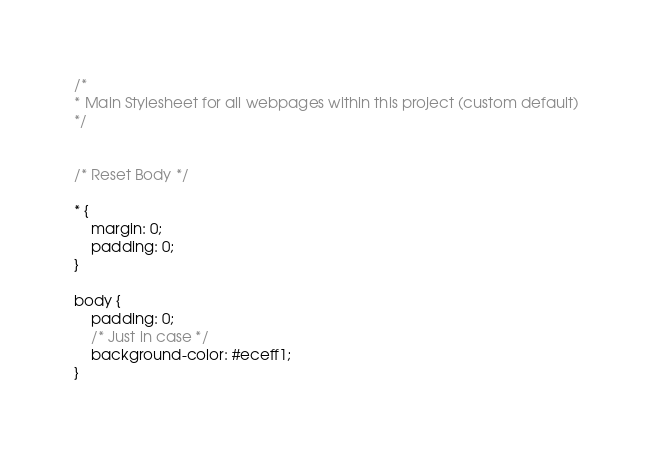<code> <loc_0><loc_0><loc_500><loc_500><_CSS_>/*
* Main Stylesheet for all webpages within this project (custom default)
*/


/* Reset Body */

* {
    margin: 0;
    padding: 0;
}

body {
    padding: 0;
    /* Just in case */
    background-color: #eceff1;
}
</code> 